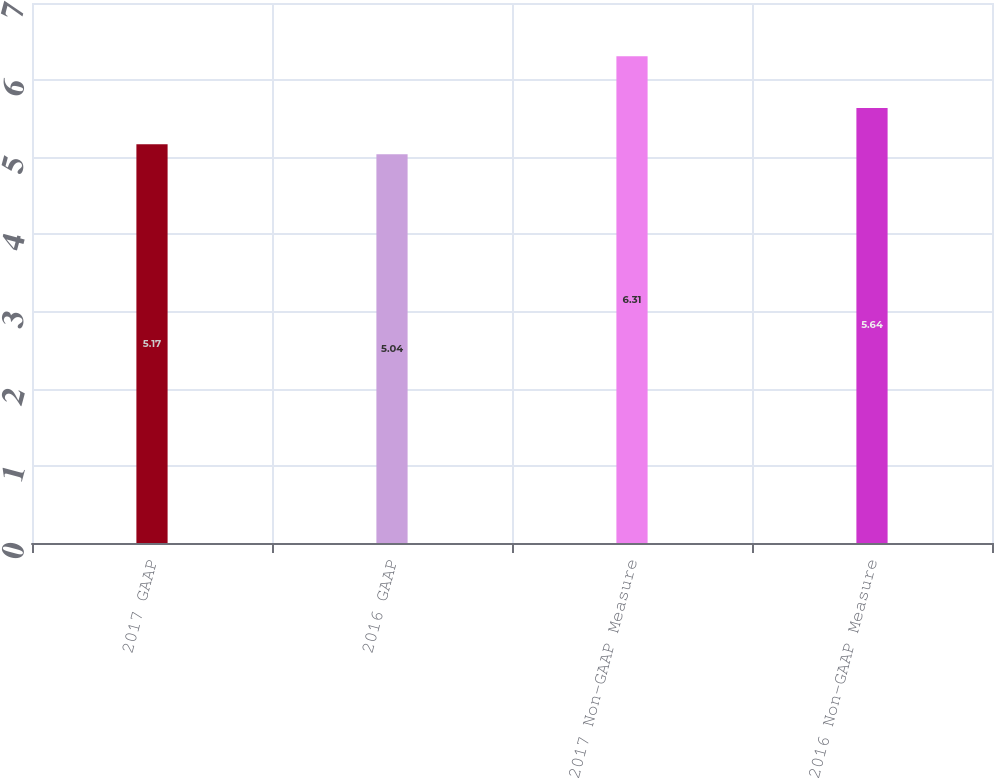Convert chart to OTSL. <chart><loc_0><loc_0><loc_500><loc_500><bar_chart><fcel>2017 GAAP<fcel>2016 GAAP<fcel>2017 Non-GAAP Measure<fcel>2016 Non-GAAP Measure<nl><fcel>5.17<fcel>5.04<fcel>6.31<fcel>5.64<nl></chart> 